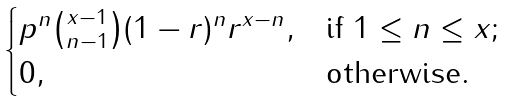Convert formula to latex. <formula><loc_0><loc_0><loc_500><loc_500>\begin{cases} p ^ { n } \binom { x - 1 } { n - 1 } ( 1 - r ) ^ { n } r ^ { x - n } , & \text {if } 1 \leq n \leq x ; \\ 0 , & \text {otherwise} . \end{cases}</formula> 